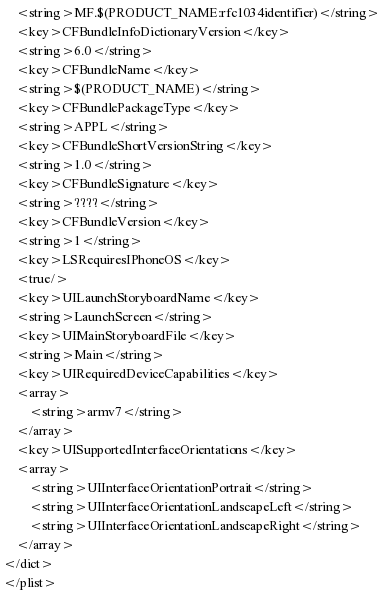<code> <loc_0><loc_0><loc_500><loc_500><_XML_>	<string>MF.$(PRODUCT_NAME:rfc1034identifier)</string>
	<key>CFBundleInfoDictionaryVersion</key>
	<string>6.0</string>
	<key>CFBundleName</key>
	<string>$(PRODUCT_NAME)</string>
	<key>CFBundlePackageType</key>
	<string>APPL</string>
	<key>CFBundleShortVersionString</key>
	<string>1.0</string>
	<key>CFBundleSignature</key>
	<string>????</string>
	<key>CFBundleVersion</key>
	<string>1</string>
	<key>LSRequiresIPhoneOS</key>
	<true/>
	<key>UILaunchStoryboardName</key>
	<string>LaunchScreen</string>
	<key>UIMainStoryboardFile</key>
	<string>Main</string>
	<key>UIRequiredDeviceCapabilities</key>
	<array>
		<string>armv7</string>
	</array>
	<key>UISupportedInterfaceOrientations</key>
	<array>
		<string>UIInterfaceOrientationPortrait</string>
		<string>UIInterfaceOrientationLandscapeLeft</string>
		<string>UIInterfaceOrientationLandscapeRight</string>
	</array>
</dict>
</plist>
</code> 